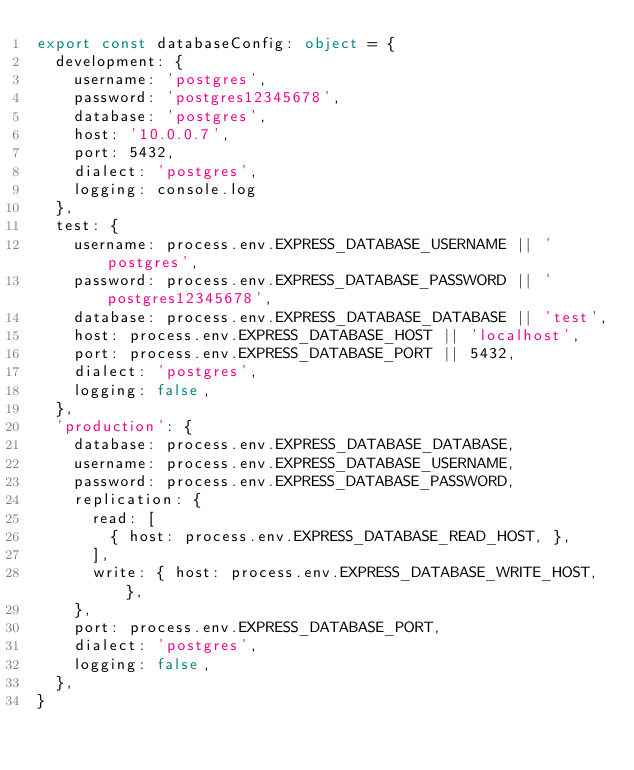<code> <loc_0><loc_0><loc_500><loc_500><_TypeScript_>export const databaseConfig: object = {
  development: {
    username: 'postgres',
    password: 'postgres12345678',
    database: 'postgres',
    host: '10.0.0.7',
    port: 5432,
    dialect: 'postgres',
    logging: console.log
  },
  test: {
    username: process.env.EXPRESS_DATABASE_USERNAME || 'postgres',
    password: process.env.EXPRESS_DATABASE_PASSWORD || 'postgres12345678',
    database: process.env.EXPRESS_DATABASE_DATABASE || 'test',
    host: process.env.EXPRESS_DATABASE_HOST || 'localhost',
    port: process.env.EXPRESS_DATABASE_PORT || 5432,
    dialect: 'postgres',
    logging: false,
  },
  'production': {
    database: process.env.EXPRESS_DATABASE_DATABASE,
    username: process.env.EXPRESS_DATABASE_USERNAME,
    password: process.env.EXPRESS_DATABASE_PASSWORD,
    replication: {
      read: [
        { host: process.env.EXPRESS_DATABASE_READ_HOST, },
      ],
      write: { host: process.env.EXPRESS_DATABASE_WRITE_HOST, },
    },
    port: process.env.EXPRESS_DATABASE_PORT,
    dialect: 'postgres',
    logging: false,
  },
}
</code> 